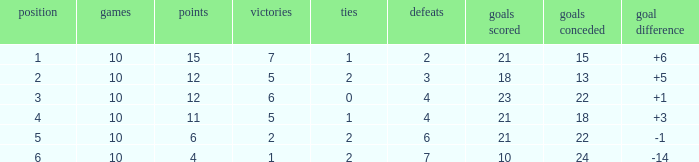Can you tell me the lowest Played that has the Position larger than 2, and the Draws smaller than 2, and the Goals against smaller than 18? None. 